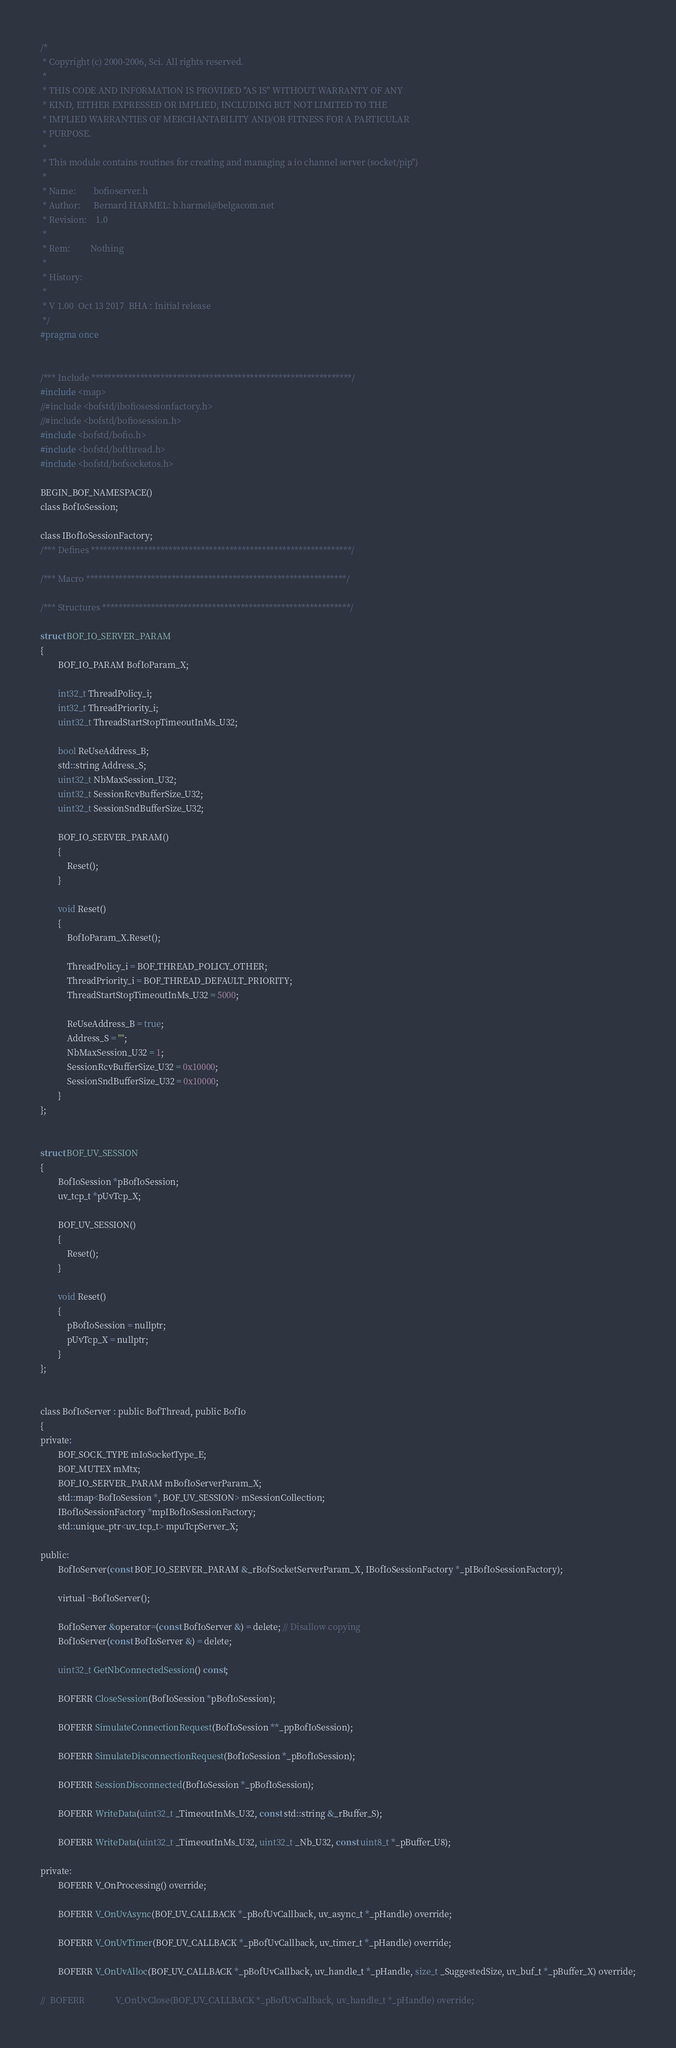Convert code to text. <code><loc_0><loc_0><loc_500><loc_500><_C_>/*
 * Copyright (c) 2000-2006, Sci. All rights reserved.
 *
 * THIS CODE AND INFORMATION IS PROVIDED "AS IS" WITHOUT WARRANTY OF ANY
 * KIND, EITHER EXPRESSED OR IMPLIED, INCLUDING BUT NOT LIMITED TO THE
 * IMPLIED WARRANTIES OF MERCHANTABILITY AND/OR FITNESS FOR A PARTICULAR
 * PURPOSE.
 *
 * This module contains routines for creating and managing a io channel server (socket/pip")
 *
 * Name:        bofioserver.h
 * Author:      Bernard HARMEL: b.harmel@belgacom.net
 * Revision:    1.0
 *
 * Rem:         Nothing
 *
 * History:
 *
 * V 1.00  Oct 13 2017  BHA : Initial release
 */
#pragma once


/*** Include ****************************************************************/
#include <map>
//#include <bofstd/ibofiosessionfactory.h>
//#include <bofstd/bofiosession.h>
#include <bofstd/bofio.h>
#include <bofstd/bofthread.h>
#include <bofstd/bofsocketos.h>

BEGIN_BOF_NAMESPACE()
class BofIoSession;

class IBofIoSessionFactory;
/*** Defines ****************************************************************/

/*** Macro ****************************************************************/

/*** Structures *************************************************************/

struct BOF_IO_SERVER_PARAM
{
		BOF_IO_PARAM BofIoParam_X;

		int32_t ThreadPolicy_i;
		int32_t ThreadPriority_i;
		uint32_t ThreadStartStopTimeoutInMs_U32;

		bool ReUseAddress_B;
		std::string Address_S;
		uint32_t NbMaxSession_U32;
		uint32_t SessionRcvBufferSize_U32;
		uint32_t SessionSndBufferSize_U32;

		BOF_IO_SERVER_PARAM()
		{
			Reset();
		}

		void Reset()
		{
			BofIoParam_X.Reset();

			ThreadPolicy_i = BOF_THREAD_POLICY_OTHER;
			ThreadPriority_i = BOF_THREAD_DEFAULT_PRIORITY;
			ThreadStartStopTimeoutInMs_U32 = 5000;

			ReUseAddress_B = true;
			Address_S = "";
			NbMaxSession_U32 = 1;
			SessionRcvBufferSize_U32 = 0x10000;
			SessionSndBufferSize_U32 = 0x10000;
		}
};


struct BOF_UV_SESSION
{
		BofIoSession *pBofIoSession;
		uv_tcp_t *pUvTcp_X;

		BOF_UV_SESSION()
		{
			Reset();
		}

		void Reset()
		{
			pBofIoSession = nullptr;
			pUvTcp_X = nullptr;
		}
};


class BofIoServer : public BofThread, public BofIo
{
private:
		BOF_SOCK_TYPE mIoSocketType_E;
		BOF_MUTEX mMtx;
		BOF_IO_SERVER_PARAM mBofIoServerParam_X;
		std::map<BofIoSession *, BOF_UV_SESSION> mSessionCollection;
		IBofIoSessionFactory *mpIBofIoSessionFactory;
		std::unique_ptr<uv_tcp_t> mpuTcpServer_X;

public:
		BofIoServer(const BOF_IO_SERVER_PARAM &_rBofSocketServerParam_X, IBofIoSessionFactory *_pIBofIoSessionFactory);

		virtual ~BofIoServer();

		BofIoServer &operator=(const BofIoServer &) = delete; // Disallow copying
		BofIoServer(const BofIoServer &) = delete;

		uint32_t GetNbConnectedSession() const;

		BOFERR CloseSession(BofIoSession *pBofIoSession);

		BOFERR SimulateConnectionRequest(BofIoSession **_ppBofIoSession);

		BOFERR SimulateDisconnectionRequest(BofIoSession *_pBofIoSession);

		BOFERR SessionDisconnected(BofIoSession *_pBofIoSession);

		BOFERR WriteData(uint32_t _TimeoutInMs_U32, const std::string &_rBuffer_S);

		BOFERR WriteData(uint32_t _TimeoutInMs_U32, uint32_t _Nb_U32, const uint8_t *_pBuffer_U8);

private:
		BOFERR V_OnProcessing() override;

		BOFERR V_OnUvAsync(BOF_UV_CALLBACK *_pBofUvCallback, uv_async_t *_pHandle) override;

		BOFERR V_OnUvTimer(BOF_UV_CALLBACK *_pBofUvCallback, uv_timer_t *_pHandle) override;

		BOFERR V_OnUvAlloc(BOF_UV_CALLBACK *_pBofUvCallback, uv_handle_t *_pHandle, size_t _SuggestedSize, uv_buf_t *_pBuffer_X) override;

//	BOFERR				V_OnUvClose(BOF_UV_CALLBACK *_pBofUvCallback, uv_handle_t *_pHandle) override;</code> 